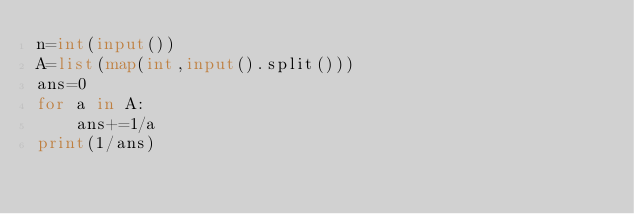<code> <loc_0><loc_0><loc_500><loc_500><_Python_>n=int(input())
A=list(map(int,input().split()))
ans=0
for a in A:
    ans+=1/a
print(1/ans)</code> 